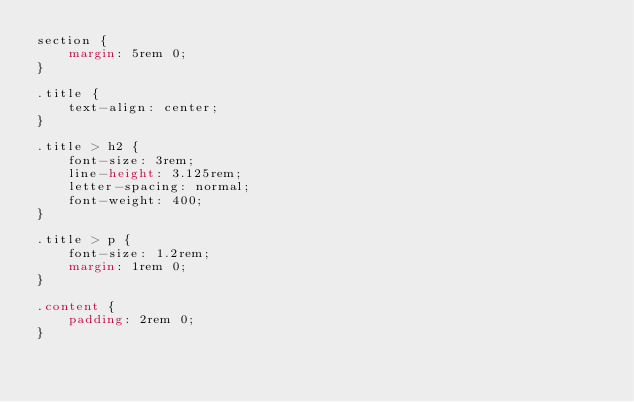Convert code to text. <code><loc_0><loc_0><loc_500><loc_500><_CSS_>section {
	margin: 5rem 0;
}

.title {
	text-align: center;
}

.title > h2 {
	font-size: 3rem;
	line-height: 3.125rem;
	letter-spacing: normal;
	font-weight: 400;
}

.title > p {
	font-size: 1.2rem;
	margin: 1rem 0;
}

.content {
	padding: 2rem 0;
}
</code> 